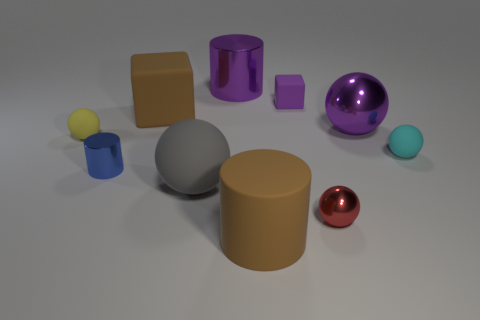How would you describe the difference in texture between the large brown block and the gray sphere? The large brown block has a flat, matte finish, indicating a uniformly smooth texture which scatters light evenly. In contrast, the gray sphere has a slightly reflective surface that suggests a smoother texture, possibly a semi-gloss finish, that reflects light more directly than the brown block. 